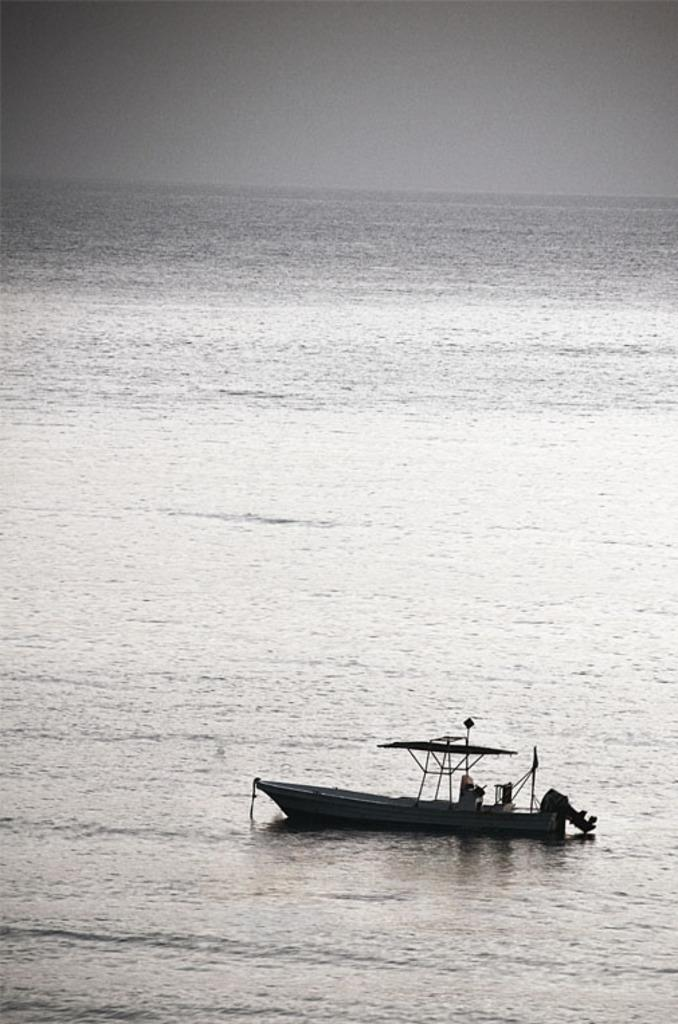What is the main subject of the image? The main subject of the image is a boat. Where is the boat located? The boat is on the water. What else can be seen in the image besides the boat? There is a sky visible in the image. What date is marked on the calendar in the image? There is no calendar present in the image. What type of rifle is being used by the person on the boat in the image? There is no person or rifle present in the image; it only features a boat on the water and a visible sky. 